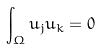Convert formula to latex. <formula><loc_0><loc_0><loc_500><loc_500>\int _ { \Omega } u _ { j } u _ { k } = 0</formula> 